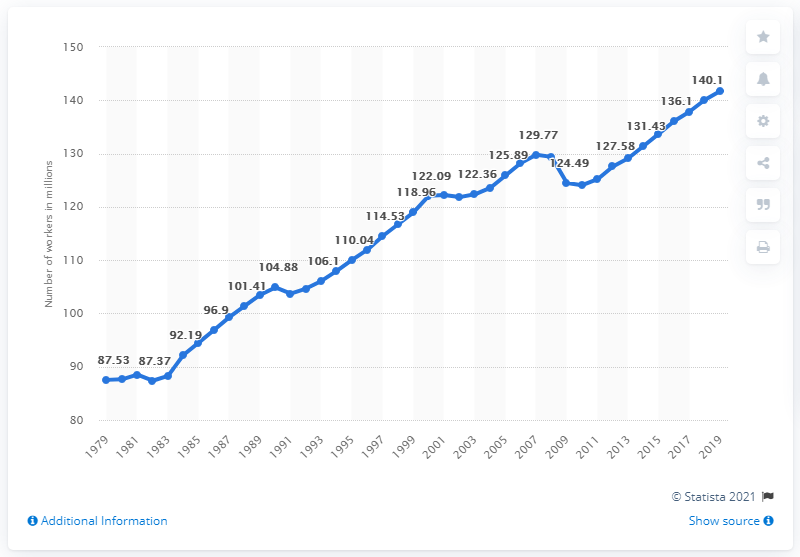List a handful of essential elements in this visual. In 2019, there were 141.74 million people employed as wage and salary workers in the United States. 